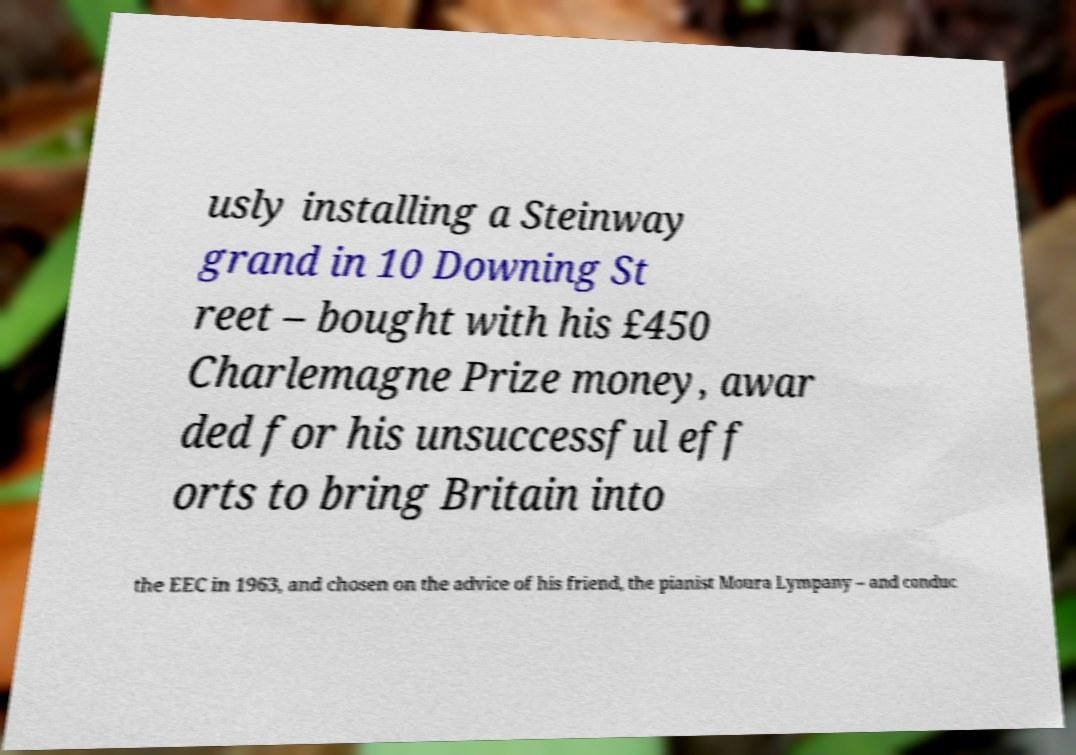For documentation purposes, I need the text within this image transcribed. Could you provide that? usly installing a Steinway grand in 10 Downing St reet – bought with his £450 Charlemagne Prize money, awar ded for his unsuccessful eff orts to bring Britain into the EEC in 1963, and chosen on the advice of his friend, the pianist Moura Lympany – and conduc 